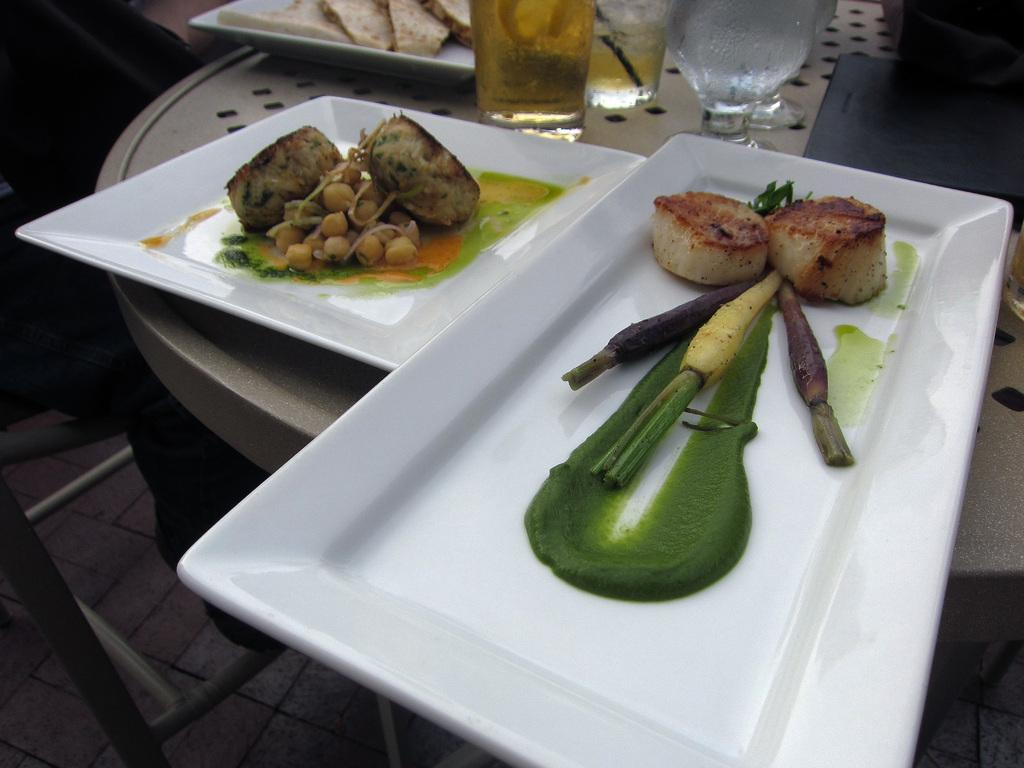What type of food is on the plate with the green sauce in the image? The image does not specify the type of food with the green sauce, only that there is food with a green sauce on a plate. What other items are on the plate with sprouts in the image? The image only mentions that there is food and sprouts on the plate. How many water glasses are visible in the image? The provided facts do not specify the number of water glasses in the image. Where are all the items mentioned located? All the items mentioned are on a table in the image. What type of badge is visible on the table in the image? There is no badge present in the image. What tax is being discussed in relation to the food on the plates in the image? There is no mention of taxes or any discussion about taxes in the image. 